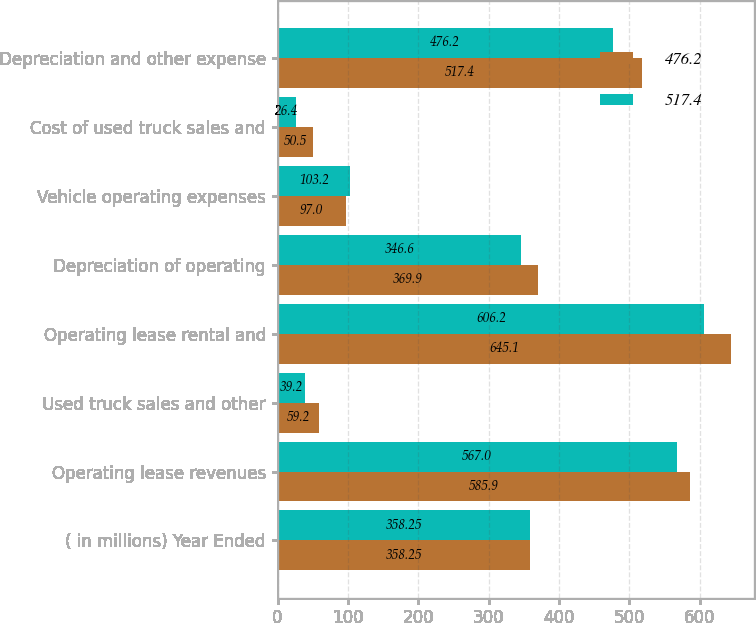Convert chart to OTSL. <chart><loc_0><loc_0><loc_500><loc_500><stacked_bar_chart><ecel><fcel>( in millions) Year Ended<fcel>Operating lease revenues<fcel>Used truck sales and other<fcel>Operating lease rental and<fcel>Depreciation of operating<fcel>Vehicle operating expenses<fcel>Cost of used truck sales and<fcel>Depreciation and other expense<nl><fcel>476.2<fcel>358.25<fcel>585.9<fcel>59.2<fcel>645.1<fcel>369.9<fcel>97<fcel>50.5<fcel>517.4<nl><fcel>517.4<fcel>358.25<fcel>567<fcel>39.2<fcel>606.2<fcel>346.6<fcel>103.2<fcel>26.4<fcel>476.2<nl></chart> 